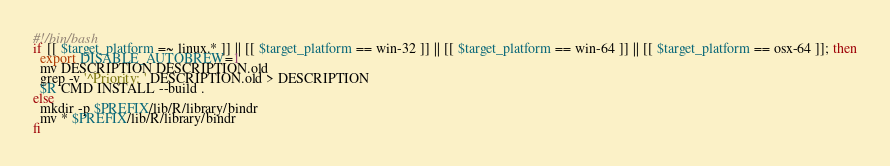<code> <loc_0><loc_0><loc_500><loc_500><_Bash_>
#!/bin/bash
if [[ $target_platform =~ linux.* ]] || [[ $target_platform == win-32 ]] || [[ $target_platform == win-64 ]] || [[ $target_platform == osx-64 ]]; then
  export DISABLE_AUTOBREW=1
  mv DESCRIPTION DESCRIPTION.old
  grep -v '^Priority: ' DESCRIPTION.old > DESCRIPTION
  $R CMD INSTALL --build .
else
  mkdir -p $PREFIX/lib/R/library/bindr
  mv * $PREFIX/lib/R/library/bindr
fi
</code> 